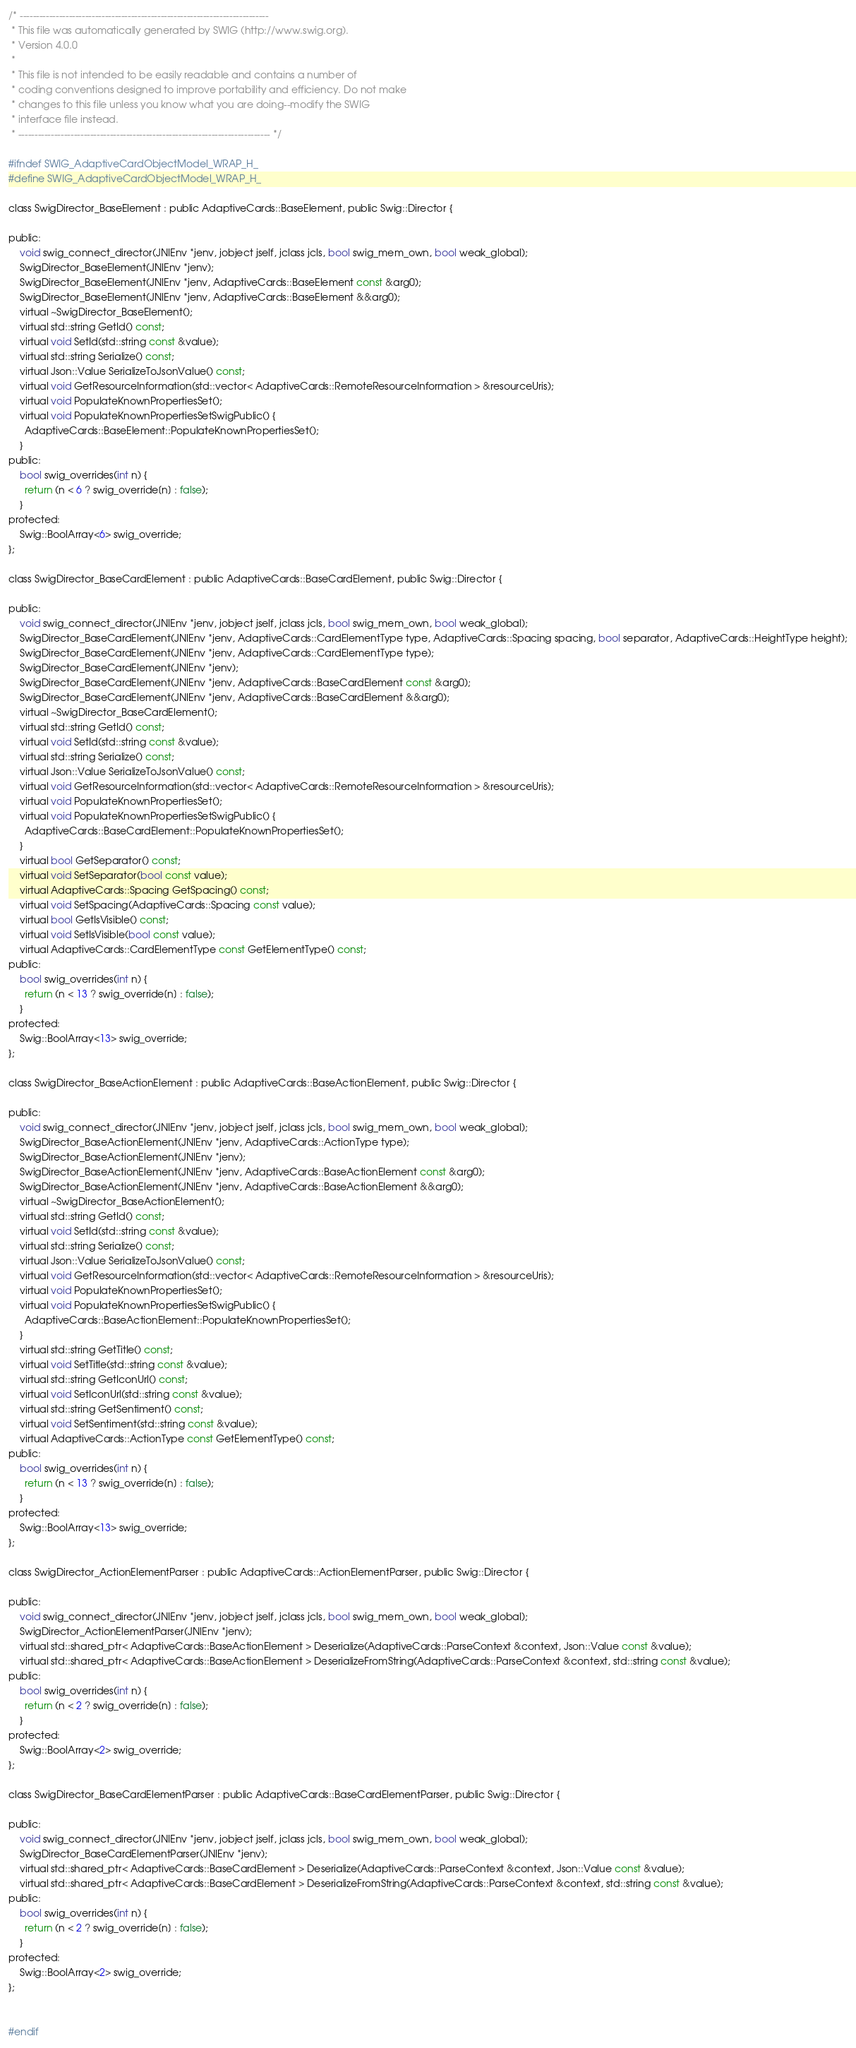Convert code to text. <code><loc_0><loc_0><loc_500><loc_500><_C_>/* ----------------------------------------------------------------------------
 * This file was automatically generated by SWIG (http://www.swig.org).
 * Version 4.0.0
 *
 * This file is not intended to be easily readable and contains a number of
 * coding conventions designed to improve portability and efficiency. Do not make
 * changes to this file unless you know what you are doing--modify the SWIG
 * interface file instead.
 * ----------------------------------------------------------------------------- */

#ifndef SWIG_AdaptiveCardObjectModel_WRAP_H_
#define SWIG_AdaptiveCardObjectModel_WRAP_H_

class SwigDirector_BaseElement : public AdaptiveCards::BaseElement, public Swig::Director {

public:
    void swig_connect_director(JNIEnv *jenv, jobject jself, jclass jcls, bool swig_mem_own, bool weak_global);
    SwigDirector_BaseElement(JNIEnv *jenv);
    SwigDirector_BaseElement(JNIEnv *jenv, AdaptiveCards::BaseElement const &arg0);
    SwigDirector_BaseElement(JNIEnv *jenv, AdaptiveCards::BaseElement &&arg0);
    virtual ~SwigDirector_BaseElement();
    virtual std::string GetId() const;
    virtual void SetId(std::string const &value);
    virtual std::string Serialize() const;
    virtual Json::Value SerializeToJsonValue() const;
    virtual void GetResourceInformation(std::vector< AdaptiveCards::RemoteResourceInformation > &resourceUris);
    virtual void PopulateKnownPropertiesSet();
    virtual void PopulateKnownPropertiesSetSwigPublic() {
      AdaptiveCards::BaseElement::PopulateKnownPropertiesSet();
    }
public:
    bool swig_overrides(int n) {
      return (n < 6 ? swig_override[n] : false);
    }
protected:
    Swig::BoolArray<6> swig_override;
};

class SwigDirector_BaseCardElement : public AdaptiveCards::BaseCardElement, public Swig::Director {

public:
    void swig_connect_director(JNIEnv *jenv, jobject jself, jclass jcls, bool swig_mem_own, bool weak_global);
    SwigDirector_BaseCardElement(JNIEnv *jenv, AdaptiveCards::CardElementType type, AdaptiveCards::Spacing spacing, bool separator, AdaptiveCards::HeightType height);
    SwigDirector_BaseCardElement(JNIEnv *jenv, AdaptiveCards::CardElementType type);
    SwigDirector_BaseCardElement(JNIEnv *jenv);
    SwigDirector_BaseCardElement(JNIEnv *jenv, AdaptiveCards::BaseCardElement const &arg0);
    SwigDirector_BaseCardElement(JNIEnv *jenv, AdaptiveCards::BaseCardElement &&arg0);
    virtual ~SwigDirector_BaseCardElement();
    virtual std::string GetId() const;
    virtual void SetId(std::string const &value);
    virtual std::string Serialize() const;
    virtual Json::Value SerializeToJsonValue() const;
    virtual void GetResourceInformation(std::vector< AdaptiveCards::RemoteResourceInformation > &resourceUris);
    virtual void PopulateKnownPropertiesSet();
    virtual void PopulateKnownPropertiesSetSwigPublic() {
      AdaptiveCards::BaseCardElement::PopulateKnownPropertiesSet();
    }
    virtual bool GetSeparator() const;
    virtual void SetSeparator(bool const value);
    virtual AdaptiveCards::Spacing GetSpacing() const;
    virtual void SetSpacing(AdaptiveCards::Spacing const value);
    virtual bool GetIsVisible() const;
    virtual void SetIsVisible(bool const value);
    virtual AdaptiveCards::CardElementType const GetElementType() const;
public:
    bool swig_overrides(int n) {
      return (n < 13 ? swig_override[n] : false);
    }
protected:
    Swig::BoolArray<13> swig_override;
};

class SwigDirector_BaseActionElement : public AdaptiveCards::BaseActionElement, public Swig::Director {

public:
    void swig_connect_director(JNIEnv *jenv, jobject jself, jclass jcls, bool swig_mem_own, bool weak_global);
    SwigDirector_BaseActionElement(JNIEnv *jenv, AdaptiveCards::ActionType type);
    SwigDirector_BaseActionElement(JNIEnv *jenv);
    SwigDirector_BaseActionElement(JNIEnv *jenv, AdaptiveCards::BaseActionElement const &arg0);
    SwigDirector_BaseActionElement(JNIEnv *jenv, AdaptiveCards::BaseActionElement &&arg0);
    virtual ~SwigDirector_BaseActionElement();
    virtual std::string GetId() const;
    virtual void SetId(std::string const &value);
    virtual std::string Serialize() const;
    virtual Json::Value SerializeToJsonValue() const;
    virtual void GetResourceInformation(std::vector< AdaptiveCards::RemoteResourceInformation > &resourceUris);
    virtual void PopulateKnownPropertiesSet();
    virtual void PopulateKnownPropertiesSetSwigPublic() {
      AdaptiveCards::BaseActionElement::PopulateKnownPropertiesSet();
    }
    virtual std::string GetTitle() const;
    virtual void SetTitle(std::string const &value);
    virtual std::string GetIconUrl() const;
    virtual void SetIconUrl(std::string const &value);
    virtual std::string GetSentiment() const;
    virtual void SetSentiment(std::string const &value);
    virtual AdaptiveCards::ActionType const GetElementType() const;
public:
    bool swig_overrides(int n) {
      return (n < 13 ? swig_override[n] : false);
    }
protected:
    Swig::BoolArray<13> swig_override;
};

class SwigDirector_ActionElementParser : public AdaptiveCards::ActionElementParser, public Swig::Director {

public:
    void swig_connect_director(JNIEnv *jenv, jobject jself, jclass jcls, bool swig_mem_own, bool weak_global);
    SwigDirector_ActionElementParser(JNIEnv *jenv);
    virtual std::shared_ptr< AdaptiveCards::BaseActionElement > Deserialize(AdaptiveCards::ParseContext &context, Json::Value const &value);
    virtual std::shared_ptr< AdaptiveCards::BaseActionElement > DeserializeFromString(AdaptiveCards::ParseContext &context, std::string const &value);
public:
    bool swig_overrides(int n) {
      return (n < 2 ? swig_override[n] : false);
    }
protected:
    Swig::BoolArray<2> swig_override;
};

class SwigDirector_BaseCardElementParser : public AdaptiveCards::BaseCardElementParser, public Swig::Director {

public:
    void swig_connect_director(JNIEnv *jenv, jobject jself, jclass jcls, bool swig_mem_own, bool weak_global);
    SwigDirector_BaseCardElementParser(JNIEnv *jenv);
    virtual std::shared_ptr< AdaptiveCards::BaseCardElement > Deserialize(AdaptiveCards::ParseContext &context, Json::Value const &value);
    virtual std::shared_ptr< AdaptiveCards::BaseCardElement > DeserializeFromString(AdaptiveCards::ParseContext &context, std::string const &value);
public:
    bool swig_overrides(int n) {
      return (n < 2 ? swig_override[n] : false);
    }
protected:
    Swig::BoolArray<2> swig_override;
};


#endif
</code> 